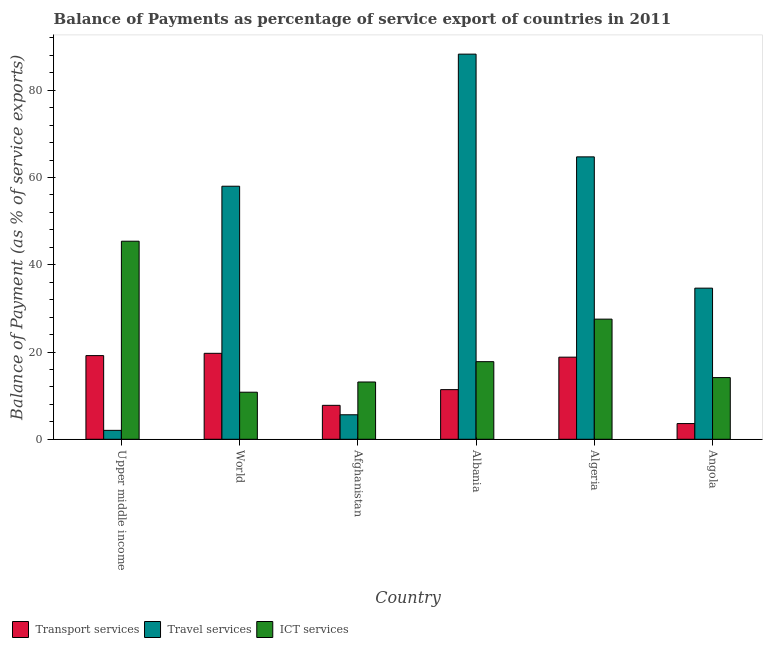How many different coloured bars are there?
Your response must be concise. 3. Are the number of bars per tick equal to the number of legend labels?
Offer a terse response. Yes. Are the number of bars on each tick of the X-axis equal?
Your response must be concise. Yes. How many bars are there on the 2nd tick from the right?
Ensure brevity in your answer.  3. What is the label of the 3rd group of bars from the left?
Your response must be concise. Afghanistan. In how many cases, is the number of bars for a given country not equal to the number of legend labels?
Make the answer very short. 0. What is the balance of payment of transport services in Algeria?
Offer a very short reply. 18.82. Across all countries, what is the maximum balance of payment of transport services?
Offer a very short reply. 19.7. Across all countries, what is the minimum balance of payment of ict services?
Offer a very short reply. 10.79. In which country was the balance of payment of transport services maximum?
Your answer should be very brief. World. In which country was the balance of payment of travel services minimum?
Keep it short and to the point. Upper middle income. What is the total balance of payment of transport services in the graph?
Keep it short and to the point. 80.46. What is the difference between the balance of payment of travel services in Afghanistan and that in Algeria?
Provide a short and direct response. -59.12. What is the difference between the balance of payment of travel services in Algeria and the balance of payment of transport services in Albania?
Ensure brevity in your answer.  53.36. What is the average balance of payment of travel services per country?
Make the answer very short. 42.22. What is the difference between the balance of payment of travel services and balance of payment of ict services in Upper middle income?
Provide a short and direct response. -43.36. What is the ratio of the balance of payment of travel services in Albania to that in World?
Your answer should be compact. 1.52. Is the balance of payment of travel services in Afghanistan less than that in Algeria?
Offer a very short reply. Yes. Is the difference between the balance of payment of travel services in Angola and World greater than the difference between the balance of payment of transport services in Angola and World?
Provide a succinct answer. No. What is the difference between the highest and the second highest balance of payment of travel services?
Offer a very short reply. 23.55. What is the difference between the highest and the lowest balance of payment of transport services?
Your answer should be very brief. 16.1. What does the 1st bar from the left in Angola represents?
Your answer should be very brief. Transport services. What does the 1st bar from the right in Angola represents?
Make the answer very short. ICT services. Are all the bars in the graph horizontal?
Your response must be concise. No. How many countries are there in the graph?
Provide a short and direct response. 6. Does the graph contain any zero values?
Offer a very short reply. No. Does the graph contain grids?
Give a very brief answer. No. Where does the legend appear in the graph?
Your response must be concise. Bottom left. What is the title of the graph?
Keep it short and to the point. Balance of Payments as percentage of service export of countries in 2011. Does "Ireland" appear as one of the legend labels in the graph?
Your answer should be compact. No. What is the label or title of the Y-axis?
Your response must be concise. Balance of Payment (as % of service exports). What is the Balance of Payment (as % of service exports) in Transport services in Upper middle income?
Your response must be concise. 19.18. What is the Balance of Payment (as % of service exports) in Travel services in Upper middle income?
Provide a succinct answer. 2.05. What is the Balance of Payment (as % of service exports) of ICT services in Upper middle income?
Provide a succinct answer. 45.4. What is the Balance of Payment (as % of service exports) of Transport services in World?
Make the answer very short. 19.7. What is the Balance of Payment (as % of service exports) in Travel services in World?
Provide a short and direct response. 58. What is the Balance of Payment (as % of service exports) in ICT services in World?
Provide a succinct answer. 10.79. What is the Balance of Payment (as % of service exports) of Transport services in Afghanistan?
Make the answer very short. 7.78. What is the Balance of Payment (as % of service exports) in Travel services in Afghanistan?
Your answer should be very brief. 5.62. What is the Balance of Payment (as % of service exports) of ICT services in Afghanistan?
Offer a terse response. 13.13. What is the Balance of Payment (as % of service exports) in Transport services in Albania?
Provide a short and direct response. 11.38. What is the Balance of Payment (as % of service exports) of Travel services in Albania?
Provide a succinct answer. 88.28. What is the Balance of Payment (as % of service exports) of ICT services in Albania?
Offer a terse response. 17.79. What is the Balance of Payment (as % of service exports) in Transport services in Algeria?
Your answer should be compact. 18.82. What is the Balance of Payment (as % of service exports) of Travel services in Algeria?
Keep it short and to the point. 64.74. What is the Balance of Payment (as % of service exports) in ICT services in Algeria?
Your answer should be compact. 27.54. What is the Balance of Payment (as % of service exports) of Transport services in Angola?
Ensure brevity in your answer.  3.6. What is the Balance of Payment (as % of service exports) in Travel services in Angola?
Offer a terse response. 34.64. What is the Balance of Payment (as % of service exports) in ICT services in Angola?
Keep it short and to the point. 14.14. Across all countries, what is the maximum Balance of Payment (as % of service exports) in Transport services?
Your answer should be compact. 19.7. Across all countries, what is the maximum Balance of Payment (as % of service exports) of Travel services?
Provide a short and direct response. 88.28. Across all countries, what is the maximum Balance of Payment (as % of service exports) of ICT services?
Give a very brief answer. 45.4. Across all countries, what is the minimum Balance of Payment (as % of service exports) of Transport services?
Offer a terse response. 3.6. Across all countries, what is the minimum Balance of Payment (as % of service exports) in Travel services?
Your answer should be compact. 2.05. Across all countries, what is the minimum Balance of Payment (as % of service exports) in ICT services?
Ensure brevity in your answer.  10.79. What is the total Balance of Payment (as % of service exports) in Transport services in the graph?
Provide a short and direct response. 80.46. What is the total Balance of Payment (as % of service exports) of Travel services in the graph?
Offer a terse response. 253.33. What is the total Balance of Payment (as % of service exports) in ICT services in the graph?
Your answer should be compact. 128.79. What is the difference between the Balance of Payment (as % of service exports) of Transport services in Upper middle income and that in World?
Offer a terse response. -0.52. What is the difference between the Balance of Payment (as % of service exports) in Travel services in Upper middle income and that in World?
Your answer should be compact. -55.96. What is the difference between the Balance of Payment (as % of service exports) of ICT services in Upper middle income and that in World?
Offer a very short reply. 34.61. What is the difference between the Balance of Payment (as % of service exports) of Transport services in Upper middle income and that in Afghanistan?
Provide a short and direct response. 11.4. What is the difference between the Balance of Payment (as % of service exports) of Travel services in Upper middle income and that in Afghanistan?
Your response must be concise. -3.57. What is the difference between the Balance of Payment (as % of service exports) of ICT services in Upper middle income and that in Afghanistan?
Your response must be concise. 32.27. What is the difference between the Balance of Payment (as % of service exports) in Transport services in Upper middle income and that in Albania?
Make the answer very short. 7.8. What is the difference between the Balance of Payment (as % of service exports) of Travel services in Upper middle income and that in Albania?
Your answer should be very brief. -86.24. What is the difference between the Balance of Payment (as % of service exports) of ICT services in Upper middle income and that in Albania?
Your answer should be compact. 27.61. What is the difference between the Balance of Payment (as % of service exports) in Transport services in Upper middle income and that in Algeria?
Ensure brevity in your answer.  0.36. What is the difference between the Balance of Payment (as % of service exports) in Travel services in Upper middle income and that in Algeria?
Make the answer very short. -62.69. What is the difference between the Balance of Payment (as % of service exports) in ICT services in Upper middle income and that in Algeria?
Give a very brief answer. 17.86. What is the difference between the Balance of Payment (as % of service exports) in Transport services in Upper middle income and that in Angola?
Your response must be concise. 15.58. What is the difference between the Balance of Payment (as % of service exports) in Travel services in Upper middle income and that in Angola?
Give a very brief answer. -32.6. What is the difference between the Balance of Payment (as % of service exports) in ICT services in Upper middle income and that in Angola?
Your answer should be very brief. 31.26. What is the difference between the Balance of Payment (as % of service exports) of Transport services in World and that in Afghanistan?
Offer a terse response. 11.92. What is the difference between the Balance of Payment (as % of service exports) in Travel services in World and that in Afghanistan?
Your answer should be very brief. 52.39. What is the difference between the Balance of Payment (as % of service exports) of ICT services in World and that in Afghanistan?
Offer a terse response. -2.34. What is the difference between the Balance of Payment (as % of service exports) in Transport services in World and that in Albania?
Your response must be concise. 8.32. What is the difference between the Balance of Payment (as % of service exports) of Travel services in World and that in Albania?
Ensure brevity in your answer.  -30.28. What is the difference between the Balance of Payment (as % of service exports) of ICT services in World and that in Albania?
Make the answer very short. -7. What is the difference between the Balance of Payment (as % of service exports) of Transport services in World and that in Algeria?
Provide a succinct answer. 0.88. What is the difference between the Balance of Payment (as % of service exports) of Travel services in World and that in Algeria?
Make the answer very short. -6.73. What is the difference between the Balance of Payment (as % of service exports) in ICT services in World and that in Algeria?
Your answer should be very brief. -16.75. What is the difference between the Balance of Payment (as % of service exports) in Transport services in World and that in Angola?
Your answer should be very brief. 16.1. What is the difference between the Balance of Payment (as % of service exports) in Travel services in World and that in Angola?
Provide a short and direct response. 23.36. What is the difference between the Balance of Payment (as % of service exports) of ICT services in World and that in Angola?
Provide a succinct answer. -3.35. What is the difference between the Balance of Payment (as % of service exports) in Transport services in Afghanistan and that in Albania?
Give a very brief answer. -3.6. What is the difference between the Balance of Payment (as % of service exports) of Travel services in Afghanistan and that in Albania?
Your answer should be very brief. -82.67. What is the difference between the Balance of Payment (as % of service exports) in ICT services in Afghanistan and that in Albania?
Ensure brevity in your answer.  -4.66. What is the difference between the Balance of Payment (as % of service exports) of Transport services in Afghanistan and that in Algeria?
Provide a short and direct response. -11.04. What is the difference between the Balance of Payment (as % of service exports) in Travel services in Afghanistan and that in Algeria?
Make the answer very short. -59.12. What is the difference between the Balance of Payment (as % of service exports) in ICT services in Afghanistan and that in Algeria?
Provide a short and direct response. -14.41. What is the difference between the Balance of Payment (as % of service exports) in Transport services in Afghanistan and that in Angola?
Your answer should be compact. 4.18. What is the difference between the Balance of Payment (as % of service exports) of Travel services in Afghanistan and that in Angola?
Provide a succinct answer. -29.02. What is the difference between the Balance of Payment (as % of service exports) of ICT services in Afghanistan and that in Angola?
Ensure brevity in your answer.  -1.01. What is the difference between the Balance of Payment (as % of service exports) in Transport services in Albania and that in Algeria?
Keep it short and to the point. -7.44. What is the difference between the Balance of Payment (as % of service exports) of Travel services in Albania and that in Algeria?
Ensure brevity in your answer.  23.55. What is the difference between the Balance of Payment (as % of service exports) of ICT services in Albania and that in Algeria?
Your response must be concise. -9.75. What is the difference between the Balance of Payment (as % of service exports) in Transport services in Albania and that in Angola?
Offer a very short reply. 7.78. What is the difference between the Balance of Payment (as % of service exports) of Travel services in Albania and that in Angola?
Make the answer very short. 53.64. What is the difference between the Balance of Payment (as % of service exports) in ICT services in Albania and that in Angola?
Your answer should be compact. 3.65. What is the difference between the Balance of Payment (as % of service exports) in Transport services in Algeria and that in Angola?
Offer a very short reply. 15.22. What is the difference between the Balance of Payment (as % of service exports) in Travel services in Algeria and that in Angola?
Provide a short and direct response. 30.09. What is the difference between the Balance of Payment (as % of service exports) of ICT services in Algeria and that in Angola?
Offer a very short reply. 13.4. What is the difference between the Balance of Payment (as % of service exports) in Transport services in Upper middle income and the Balance of Payment (as % of service exports) in Travel services in World?
Provide a short and direct response. -38.83. What is the difference between the Balance of Payment (as % of service exports) in Transport services in Upper middle income and the Balance of Payment (as % of service exports) in ICT services in World?
Provide a succinct answer. 8.39. What is the difference between the Balance of Payment (as % of service exports) in Travel services in Upper middle income and the Balance of Payment (as % of service exports) in ICT services in World?
Keep it short and to the point. -8.74. What is the difference between the Balance of Payment (as % of service exports) in Transport services in Upper middle income and the Balance of Payment (as % of service exports) in Travel services in Afghanistan?
Provide a short and direct response. 13.56. What is the difference between the Balance of Payment (as % of service exports) in Transport services in Upper middle income and the Balance of Payment (as % of service exports) in ICT services in Afghanistan?
Your answer should be very brief. 6.05. What is the difference between the Balance of Payment (as % of service exports) of Travel services in Upper middle income and the Balance of Payment (as % of service exports) of ICT services in Afghanistan?
Offer a very short reply. -11.09. What is the difference between the Balance of Payment (as % of service exports) in Transport services in Upper middle income and the Balance of Payment (as % of service exports) in Travel services in Albania?
Your response must be concise. -69.11. What is the difference between the Balance of Payment (as % of service exports) in Transport services in Upper middle income and the Balance of Payment (as % of service exports) in ICT services in Albania?
Ensure brevity in your answer.  1.39. What is the difference between the Balance of Payment (as % of service exports) in Travel services in Upper middle income and the Balance of Payment (as % of service exports) in ICT services in Albania?
Provide a succinct answer. -15.75. What is the difference between the Balance of Payment (as % of service exports) of Transport services in Upper middle income and the Balance of Payment (as % of service exports) of Travel services in Algeria?
Offer a terse response. -45.56. What is the difference between the Balance of Payment (as % of service exports) of Transport services in Upper middle income and the Balance of Payment (as % of service exports) of ICT services in Algeria?
Ensure brevity in your answer.  -8.36. What is the difference between the Balance of Payment (as % of service exports) of Travel services in Upper middle income and the Balance of Payment (as % of service exports) of ICT services in Algeria?
Your answer should be very brief. -25.49. What is the difference between the Balance of Payment (as % of service exports) in Transport services in Upper middle income and the Balance of Payment (as % of service exports) in Travel services in Angola?
Ensure brevity in your answer.  -15.46. What is the difference between the Balance of Payment (as % of service exports) of Transport services in Upper middle income and the Balance of Payment (as % of service exports) of ICT services in Angola?
Offer a terse response. 5.04. What is the difference between the Balance of Payment (as % of service exports) in Travel services in Upper middle income and the Balance of Payment (as % of service exports) in ICT services in Angola?
Provide a succinct answer. -12.09. What is the difference between the Balance of Payment (as % of service exports) in Transport services in World and the Balance of Payment (as % of service exports) in Travel services in Afghanistan?
Offer a very short reply. 14.08. What is the difference between the Balance of Payment (as % of service exports) of Transport services in World and the Balance of Payment (as % of service exports) of ICT services in Afghanistan?
Your response must be concise. 6.57. What is the difference between the Balance of Payment (as % of service exports) in Travel services in World and the Balance of Payment (as % of service exports) in ICT services in Afghanistan?
Your answer should be very brief. 44.87. What is the difference between the Balance of Payment (as % of service exports) in Transport services in World and the Balance of Payment (as % of service exports) in Travel services in Albania?
Your answer should be compact. -68.58. What is the difference between the Balance of Payment (as % of service exports) of Transport services in World and the Balance of Payment (as % of service exports) of ICT services in Albania?
Provide a short and direct response. 1.91. What is the difference between the Balance of Payment (as % of service exports) of Travel services in World and the Balance of Payment (as % of service exports) of ICT services in Albania?
Give a very brief answer. 40.21. What is the difference between the Balance of Payment (as % of service exports) of Transport services in World and the Balance of Payment (as % of service exports) of Travel services in Algeria?
Your response must be concise. -45.03. What is the difference between the Balance of Payment (as % of service exports) of Transport services in World and the Balance of Payment (as % of service exports) of ICT services in Algeria?
Keep it short and to the point. -7.84. What is the difference between the Balance of Payment (as % of service exports) of Travel services in World and the Balance of Payment (as % of service exports) of ICT services in Algeria?
Make the answer very short. 30.47. What is the difference between the Balance of Payment (as % of service exports) of Transport services in World and the Balance of Payment (as % of service exports) of Travel services in Angola?
Give a very brief answer. -14.94. What is the difference between the Balance of Payment (as % of service exports) of Transport services in World and the Balance of Payment (as % of service exports) of ICT services in Angola?
Make the answer very short. 5.56. What is the difference between the Balance of Payment (as % of service exports) in Travel services in World and the Balance of Payment (as % of service exports) in ICT services in Angola?
Your answer should be compact. 43.86. What is the difference between the Balance of Payment (as % of service exports) in Transport services in Afghanistan and the Balance of Payment (as % of service exports) in Travel services in Albania?
Your response must be concise. -80.5. What is the difference between the Balance of Payment (as % of service exports) in Transport services in Afghanistan and the Balance of Payment (as % of service exports) in ICT services in Albania?
Ensure brevity in your answer.  -10.01. What is the difference between the Balance of Payment (as % of service exports) of Travel services in Afghanistan and the Balance of Payment (as % of service exports) of ICT services in Albania?
Give a very brief answer. -12.17. What is the difference between the Balance of Payment (as % of service exports) in Transport services in Afghanistan and the Balance of Payment (as % of service exports) in Travel services in Algeria?
Offer a very short reply. -56.96. What is the difference between the Balance of Payment (as % of service exports) in Transport services in Afghanistan and the Balance of Payment (as % of service exports) in ICT services in Algeria?
Your answer should be compact. -19.76. What is the difference between the Balance of Payment (as % of service exports) of Travel services in Afghanistan and the Balance of Payment (as % of service exports) of ICT services in Algeria?
Make the answer very short. -21.92. What is the difference between the Balance of Payment (as % of service exports) of Transport services in Afghanistan and the Balance of Payment (as % of service exports) of Travel services in Angola?
Your answer should be very brief. -26.86. What is the difference between the Balance of Payment (as % of service exports) of Transport services in Afghanistan and the Balance of Payment (as % of service exports) of ICT services in Angola?
Offer a very short reply. -6.36. What is the difference between the Balance of Payment (as % of service exports) in Travel services in Afghanistan and the Balance of Payment (as % of service exports) in ICT services in Angola?
Give a very brief answer. -8.52. What is the difference between the Balance of Payment (as % of service exports) of Transport services in Albania and the Balance of Payment (as % of service exports) of Travel services in Algeria?
Provide a succinct answer. -53.36. What is the difference between the Balance of Payment (as % of service exports) of Transport services in Albania and the Balance of Payment (as % of service exports) of ICT services in Algeria?
Ensure brevity in your answer.  -16.16. What is the difference between the Balance of Payment (as % of service exports) of Travel services in Albania and the Balance of Payment (as % of service exports) of ICT services in Algeria?
Ensure brevity in your answer.  60.75. What is the difference between the Balance of Payment (as % of service exports) in Transport services in Albania and the Balance of Payment (as % of service exports) in Travel services in Angola?
Your answer should be compact. -23.26. What is the difference between the Balance of Payment (as % of service exports) in Transport services in Albania and the Balance of Payment (as % of service exports) in ICT services in Angola?
Your answer should be very brief. -2.76. What is the difference between the Balance of Payment (as % of service exports) of Travel services in Albania and the Balance of Payment (as % of service exports) of ICT services in Angola?
Provide a short and direct response. 74.14. What is the difference between the Balance of Payment (as % of service exports) of Transport services in Algeria and the Balance of Payment (as % of service exports) of Travel services in Angola?
Make the answer very short. -15.82. What is the difference between the Balance of Payment (as % of service exports) in Transport services in Algeria and the Balance of Payment (as % of service exports) in ICT services in Angola?
Offer a terse response. 4.68. What is the difference between the Balance of Payment (as % of service exports) in Travel services in Algeria and the Balance of Payment (as % of service exports) in ICT services in Angola?
Make the answer very short. 50.6. What is the average Balance of Payment (as % of service exports) in Transport services per country?
Your answer should be compact. 13.41. What is the average Balance of Payment (as % of service exports) of Travel services per country?
Keep it short and to the point. 42.22. What is the average Balance of Payment (as % of service exports) of ICT services per country?
Keep it short and to the point. 21.47. What is the difference between the Balance of Payment (as % of service exports) of Transport services and Balance of Payment (as % of service exports) of Travel services in Upper middle income?
Your answer should be very brief. 17.13. What is the difference between the Balance of Payment (as % of service exports) of Transport services and Balance of Payment (as % of service exports) of ICT services in Upper middle income?
Keep it short and to the point. -26.22. What is the difference between the Balance of Payment (as % of service exports) in Travel services and Balance of Payment (as % of service exports) in ICT services in Upper middle income?
Give a very brief answer. -43.36. What is the difference between the Balance of Payment (as % of service exports) of Transport services and Balance of Payment (as % of service exports) of Travel services in World?
Give a very brief answer. -38.3. What is the difference between the Balance of Payment (as % of service exports) of Transport services and Balance of Payment (as % of service exports) of ICT services in World?
Keep it short and to the point. 8.91. What is the difference between the Balance of Payment (as % of service exports) in Travel services and Balance of Payment (as % of service exports) in ICT services in World?
Your answer should be very brief. 47.22. What is the difference between the Balance of Payment (as % of service exports) in Transport services and Balance of Payment (as % of service exports) in Travel services in Afghanistan?
Offer a very short reply. 2.16. What is the difference between the Balance of Payment (as % of service exports) of Transport services and Balance of Payment (as % of service exports) of ICT services in Afghanistan?
Provide a short and direct response. -5.35. What is the difference between the Balance of Payment (as % of service exports) of Travel services and Balance of Payment (as % of service exports) of ICT services in Afghanistan?
Give a very brief answer. -7.51. What is the difference between the Balance of Payment (as % of service exports) in Transport services and Balance of Payment (as % of service exports) in Travel services in Albania?
Provide a short and direct response. -76.91. What is the difference between the Balance of Payment (as % of service exports) in Transport services and Balance of Payment (as % of service exports) in ICT services in Albania?
Make the answer very short. -6.41. What is the difference between the Balance of Payment (as % of service exports) in Travel services and Balance of Payment (as % of service exports) in ICT services in Albania?
Make the answer very short. 70.49. What is the difference between the Balance of Payment (as % of service exports) in Transport services and Balance of Payment (as % of service exports) in Travel services in Algeria?
Ensure brevity in your answer.  -45.91. What is the difference between the Balance of Payment (as % of service exports) in Transport services and Balance of Payment (as % of service exports) in ICT services in Algeria?
Your answer should be very brief. -8.71. What is the difference between the Balance of Payment (as % of service exports) in Travel services and Balance of Payment (as % of service exports) in ICT services in Algeria?
Your answer should be very brief. 37.2. What is the difference between the Balance of Payment (as % of service exports) of Transport services and Balance of Payment (as % of service exports) of Travel services in Angola?
Your answer should be very brief. -31.04. What is the difference between the Balance of Payment (as % of service exports) of Transport services and Balance of Payment (as % of service exports) of ICT services in Angola?
Make the answer very short. -10.54. What is the difference between the Balance of Payment (as % of service exports) in Travel services and Balance of Payment (as % of service exports) in ICT services in Angola?
Offer a terse response. 20.5. What is the ratio of the Balance of Payment (as % of service exports) in Transport services in Upper middle income to that in World?
Keep it short and to the point. 0.97. What is the ratio of the Balance of Payment (as % of service exports) of Travel services in Upper middle income to that in World?
Provide a short and direct response. 0.04. What is the ratio of the Balance of Payment (as % of service exports) in ICT services in Upper middle income to that in World?
Keep it short and to the point. 4.21. What is the ratio of the Balance of Payment (as % of service exports) in Transport services in Upper middle income to that in Afghanistan?
Your answer should be very brief. 2.47. What is the ratio of the Balance of Payment (as % of service exports) of Travel services in Upper middle income to that in Afghanistan?
Your response must be concise. 0.36. What is the ratio of the Balance of Payment (as % of service exports) of ICT services in Upper middle income to that in Afghanistan?
Your answer should be very brief. 3.46. What is the ratio of the Balance of Payment (as % of service exports) of Transport services in Upper middle income to that in Albania?
Give a very brief answer. 1.69. What is the ratio of the Balance of Payment (as % of service exports) in Travel services in Upper middle income to that in Albania?
Offer a very short reply. 0.02. What is the ratio of the Balance of Payment (as % of service exports) in ICT services in Upper middle income to that in Albania?
Your response must be concise. 2.55. What is the ratio of the Balance of Payment (as % of service exports) of Transport services in Upper middle income to that in Algeria?
Make the answer very short. 1.02. What is the ratio of the Balance of Payment (as % of service exports) of Travel services in Upper middle income to that in Algeria?
Your response must be concise. 0.03. What is the ratio of the Balance of Payment (as % of service exports) of ICT services in Upper middle income to that in Algeria?
Your response must be concise. 1.65. What is the ratio of the Balance of Payment (as % of service exports) in Transport services in Upper middle income to that in Angola?
Ensure brevity in your answer.  5.33. What is the ratio of the Balance of Payment (as % of service exports) of Travel services in Upper middle income to that in Angola?
Your response must be concise. 0.06. What is the ratio of the Balance of Payment (as % of service exports) in ICT services in Upper middle income to that in Angola?
Provide a short and direct response. 3.21. What is the ratio of the Balance of Payment (as % of service exports) of Transport services in World to that in Afghanistan?
Your answer should be compact. 2.53. What is the ratio of the Balance of Payment (as % of service exports) in Travel services in World to that in Afghanistan?
Offer a terse response. 10.33. What is the ratio of the Balance of Payment (as % of service exports) of ICT services in World to that in Afghanistan?
Your response must be concise. 0.82. What is the ratio of the Balance of Payment (as % of service exports) in Transport services in World to that in Albania?
Provide a short and direct response. 1.73. What is the ratio of the Balance of Payment (as % of service exports) of Travel services in World to that in Albania?
Offer a terse response. 0.66. What is the ratio of the Balance of Payment (as % of service exports) in ICT services in World to that in Albania?
Provide a short and direct response. 0.61. What is the ratio of the Balance of Payment (as % of service exports) of Transport services in World to that in Algeria?
Provide a succinct answer. 1.05. What is the ratio of the Balance of Payment (as % of service exports) in Travel services in World to that in Algeria?
Make the answer very short. 0.9. What is the ratio of the Balance of Payment (as % of service exports) in ICT services in World to that in Algeria?
Your answer should be very brief. 0.39. What is the ratio of the Balance of Payment (as % of service exports) in Transport services in World to that in Angola?
Keep it short and to the point. 5.47. What is the ratio of the Balance of Payment (as % of service exports) in Travel services in World to that in Angola?
Keep it short and to the point. 1.67. What is the ratio of the Balance of Payment (as % of service exports) in ICT services in World to that in Angola?
Your answer should be very brief. 0.76. What is the ratio of the Balance of Payment (as % of service exports) of Transport services in Afghanistan to that in Albania?
Provide a short and direct response. 0.68. What is the ratio of the Balance of Payment (as % of service exports) of Travel services in Afghanistan to that in Albania?
Ensure brevity in your answer.  0.06. What is the ratio of the Balance of Payment (as % of service exports) of ICT services in Afghanistan to that in Albania?
Your answer should be very brief. 0.74. What is the ratio of the Balance of Payment (as % of service exports) in Transport services in Afghanistan to that in Algeria?
Keep it short and to the point. 0.41. What is the ratio of the Balance of Payment (as % of service exports) of Travel services in Afghanistan to that in Algeria?
Provide a succinct answer. 0.09. What is the ratio of the Balance of Payment (as % of service exports) in ICT services in Afghanistan to that in Algeria?
Make the answer very short. 0.48. What is the ratio of the Balance of Payment (as % of service exports) in Transport services in Afghanistan to that in Angola?
Your answer should be compact. 2.16. What is the ratio of the Balance of Payment (as % of service exports) in Travel services in Afghanistan to that in Angola?
Provide a short and direct response. 0.16. What is the ratio of the Balance of Payment (as % of service exports) of ICT services in Afghanistan to that in Angola?
Offer a terse response. 0.93. What is the ratio of the Balance of Payment (as % of service exports) in Transport services in Albania to that in Algeria?
Your answer should be very brief. 0.6. What is the ratio of the Balance of Payment (as % of service exports) in Travel services in Albania to that in Algeria?
Your response must be concise. 1.36. What is the ratio of the Balance of Payment (as % of service exports) in ICT services in Albania to that in Algeria?
Keep it short and to the point. 0.65. What is the ratio of the Balance of Payment (as % of service exports) of Transport services in Albania to that in Angola?
Ensure brevity in your answer.  3.16. What is the ratio of the Balance of Payment (as % of service exports) of Travel services in Albania to that in Angola?
Ensure brevity in your answer.  2.55. What is the ratio of the Balance of Payment (as % of service exports) of ICT services in Albania to that in Angola?
Keep it short and to the point. 1.26. What is the ratio of the Balance of Payment (as % of service exports) of Transport services in Algeria to that in Angola?
Your answer should be compact. 5.23. What is the ratio of the Balance of Payment (as % of service exports) in Travel services in Algeria to that in Angola?
Your answer should be very brief. 1.87. What is the ratio of the Balance of Payment (as % of service exports) in ICT services in Algeria to that in Angola?
Provide a succinct answer. 1.95. What is the difference between the highest and the second highest Balance of Payment (as % of service exports) of Transport services?
Offer a terse response. 0.52. What is the difference between the highest and the second highest Balance of Payment (as % of service exports) of Travel services?
Offer a very short reply. 23.55. What is the difference between the highest and the second highest Balance of Payment (as % of service exports) of ICT services?
Provide a succinct answer. 17.86. What is the difference between the highest and the lowest Balance of Payment (as % of service exports) of Transport services?
Offer a very short reply. 16.1. What is the difference between the highest and the lowest Balance of Payment (as % of service exports) of Travel services?
Offer a terse response. 86.24. What is the difference between the highest and the lowest Balance of Payment (as % of service exports) of ICT services?
Offer a terse response. 34.61. 